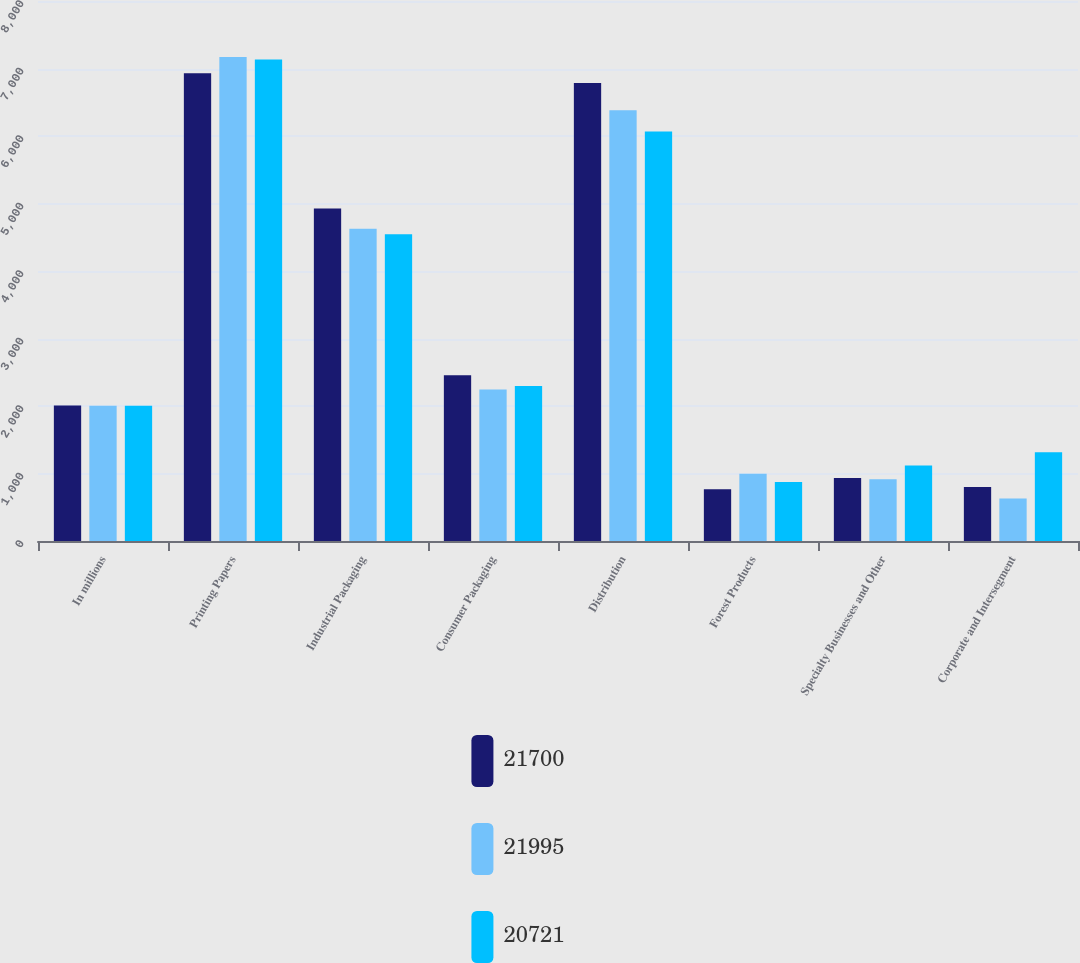Convert chart. <chart><loc_0><loc_0><loc_500><loc_500><stacked_bar_chart><ecel><fcel>In millions<fcel>Printing Papers<fcel>Industrial Packaging<fcel>Consumer Packaging<fcel>Distribution<fcel>Forest Products<fcel>Specialty Businesses and Other<fcel>Corporate and Intersegment<nl><fcel>21700<fcel>2006<fcel>6930<fcel>4925<fcel>2455<fcel>6785<fcel>765<fcel>935<fcel>800<nl><fcel>21995<fcel>2005<fcel>7170<fcel>4625<fcel>2245<fcel>6380<fcel>995<fcel>915<fcel>630<nl><fcel>20721<fcel>2004<fcel>7135<fcel>4545<fcel>2295<fcel>6065<fcel>875<fcel>1120<fcel>1314<nl></chart> 